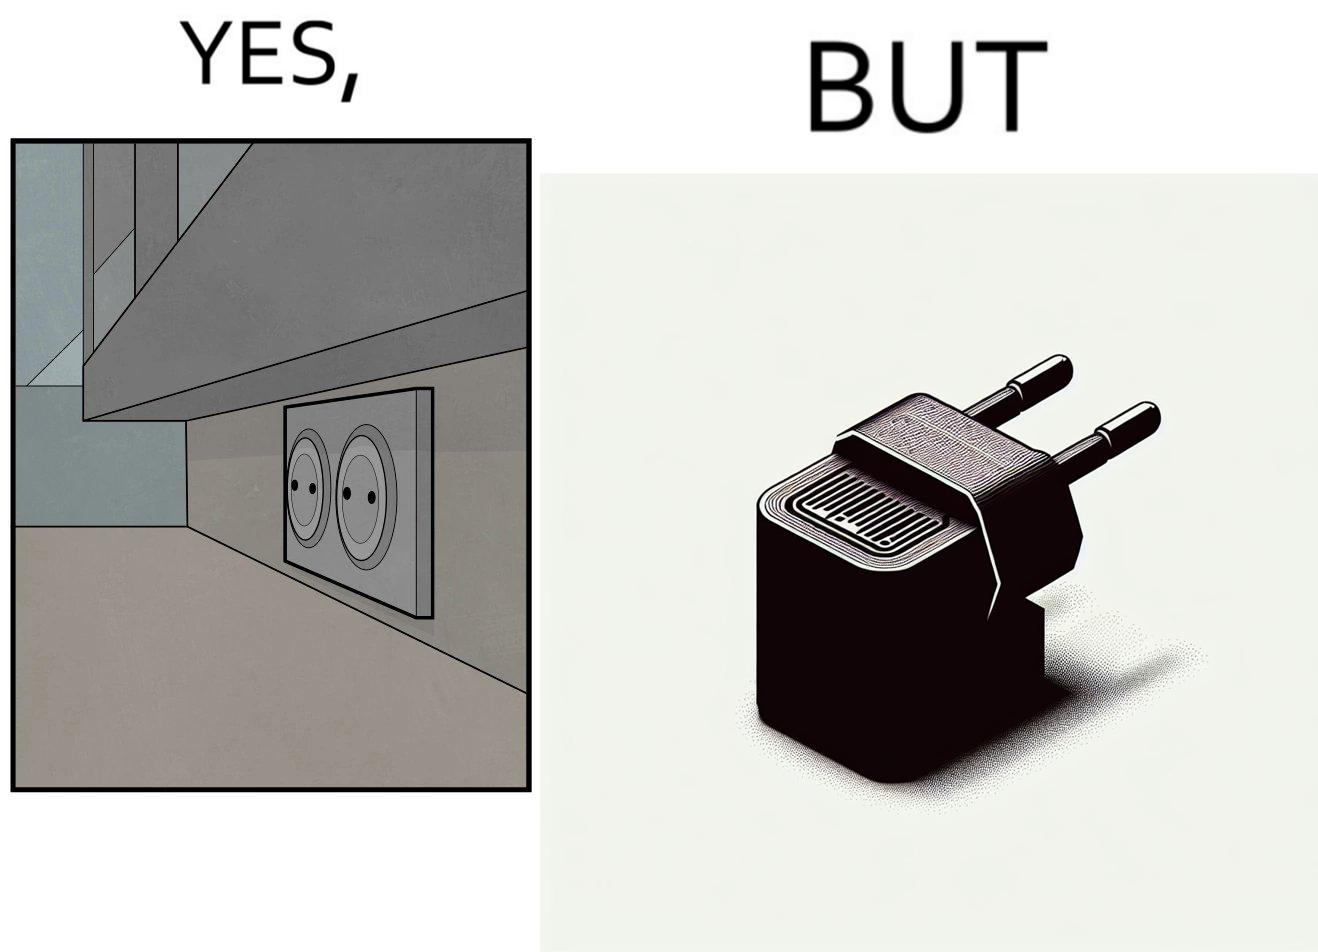Is this a satirical image? Yes, this image is satirical. 